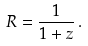<formula> <loc_0><loc_0><loc_500><loc_500>R = \frac { 1 } { 1 + z } \, .</formula> 